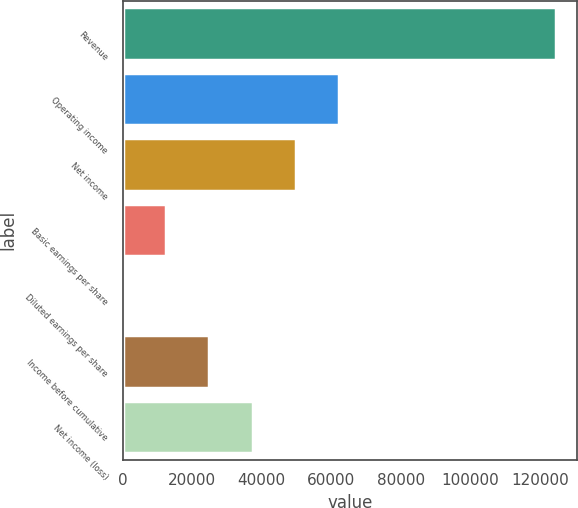Convert chart to OTSL. <chart><loc_0><loc_0><loc_500><loc_500><bar_chart><fcel>Revenue<fcel>Operating income<fcel>Net income<fcel>Basic earnings per share<fcel>Diluted earnings per share<fcel>Income before cumulative<fcel>Net income (loss)<nl><fcel>124573<fcel>62286.7<fcel>49829.4<fcel>12457.6<fcel>0.32<fcel>24914.9<fcel>37372.1<nl></chart> 